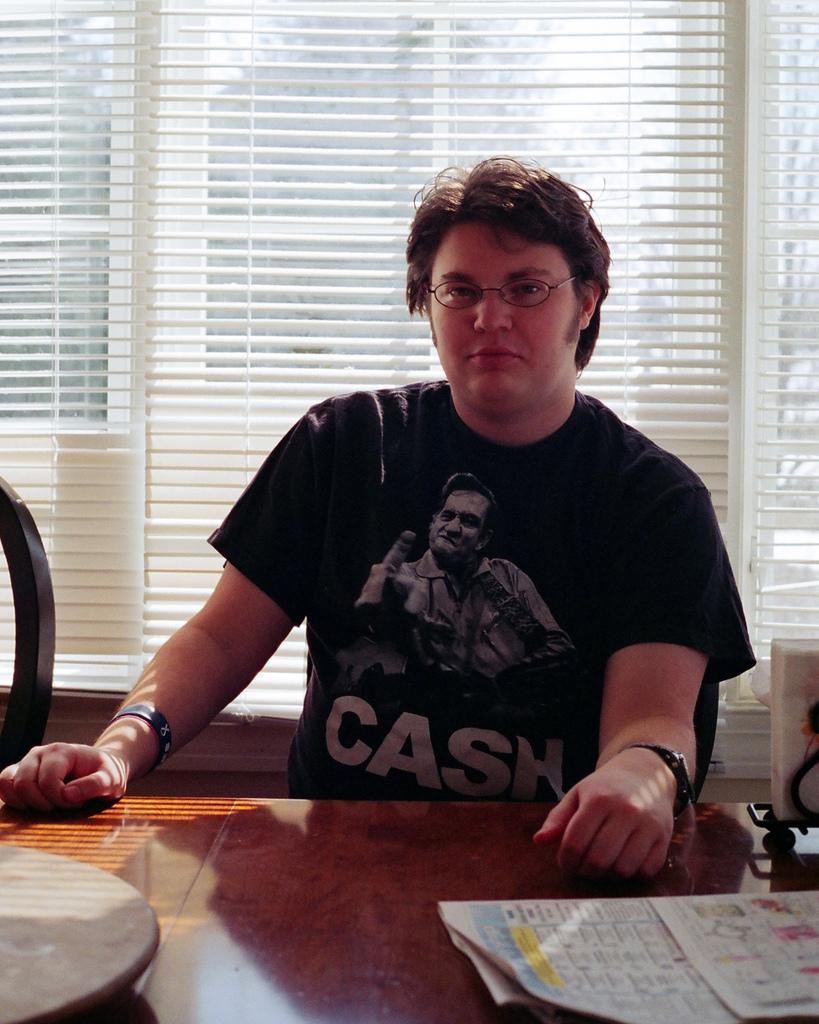What is the person in the image doing? The person is sitting in the image. What is the person wearing? The person is wearing a black shirt. What object can be seen on a table in the image? There is a paper on a table in the image. What is the color of the table? The table is brown in color. What can be seen in the background of the image? There is a window visible in the background of the image. What songs is the person singing in the image? There is no indication in the image that the person is singing any songs. 